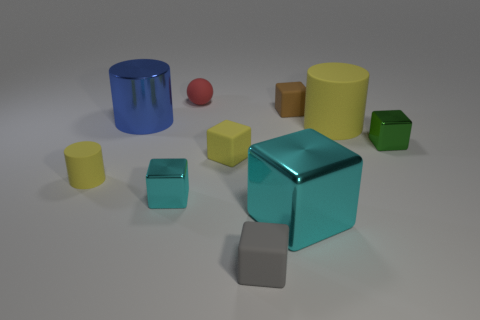Is there anything else that has the same shape as the small red matte thing?
Make the answer very short. No. Are there an equal number of brown matte things in front of the blue metallic object and large green metallic cylinders?
Your answer should be compact. Yes. How many large purple matte cylinders are there?
Keep it short and to the point. 0. The tiny object that is both on the right side of the tiny red matte thing and behind the big yellow rubber cylinder has what shape?
Offer a terse response. Cube. Is the color of the matte cylinder on the left side of the large cyan object the same as the cylinder right of the red sphere?
Ensure brevity in your answer.  Yes. There is a matte block that is the same color as the tiny cylinder; what size is it?
Give a very brief answer. Small. Are there any big blue cylinders that have the same material as the tiny green cube?
Ensure brevity in your answer.  Yes. Is the number of tiny blocks that are right of the green shiny object the same as the number of big yellow cylinders that are to the left of the tiny yellow cylinder?
Offer a terse response. Yes. What is the size of the matte cube to the right of the big cyan metal block?
Offer a very short reply. Small. What material is the cyan block in front of the tiny metal block left of the green metal thing made of?
Provide a succinct answer. Metal. 